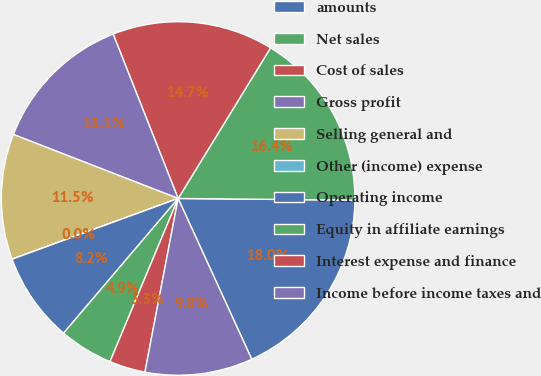Convert chart to OTSL. <chart><loc_0><loc_0><loc_500><loc_500><pie_chart><fcel>amounts<fcel>Net sales<fcel>Cost of sales<fcel>Gross profit<fcel>Selling general and<fcel>Other (income) expense<fcel>Operating income<fcel>Equity in affiliate earnings<fcel>Interest expense and finance<fcel>Income before income taxes and<nl><fcel>18.02%<fcel>16.39%<fcel>14.75%<fcel>13.11%<fcel>11.47%<fcel>0.01%<fcel>8.2%<fcel>4.92%<fcel>3.29%<fcel>9.84%<nl></chart> 